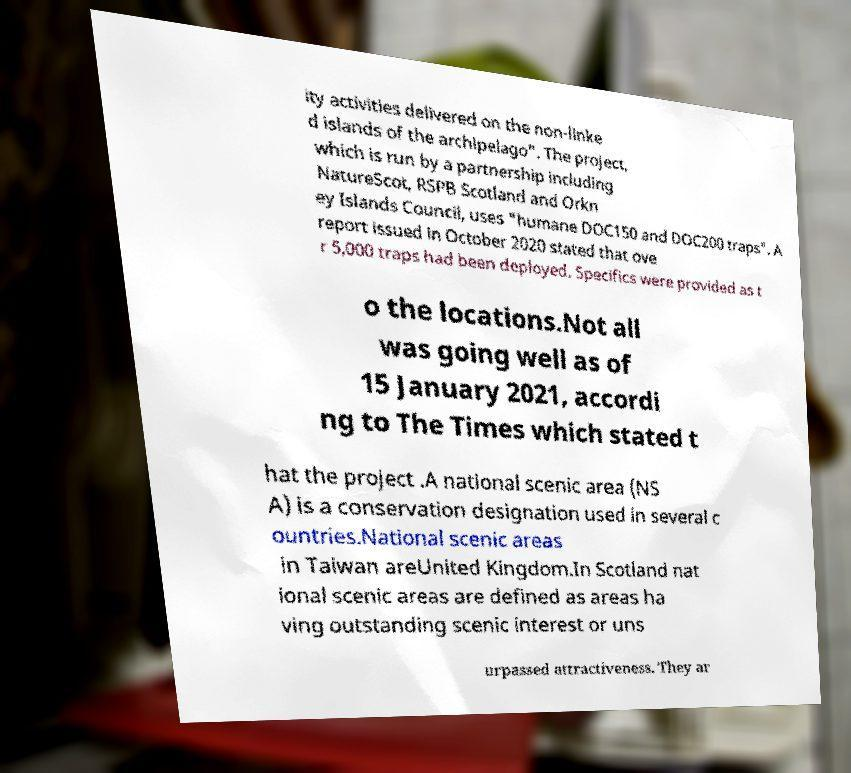For documentation purposes, I need the text within this image transcribed. Could you provide that? ity activities delivered on the non-linke d islands of the archipelago". The project, which is run by a partnership including NatureScot, RSPB Scotland and Orkn ey Islands Council, uses "humane DOC150 and DOC200 traps". A report issued in October 2020 stated that ove r 5,000 traps had been deployed. Specifics were provided as t o the locations.Not all was going well as of 15 January 2021, accordi ng to The Times which stated t hat the project .A national scenic area (NS A) is a conservation designation used in several c ountries.National scenic areas in Taiwan areUnited Kingdom.In Scotland nat ional scenic areas are defined as areas ha ving outstanding scenic interest or uns urpassed attractiveness. They ar 